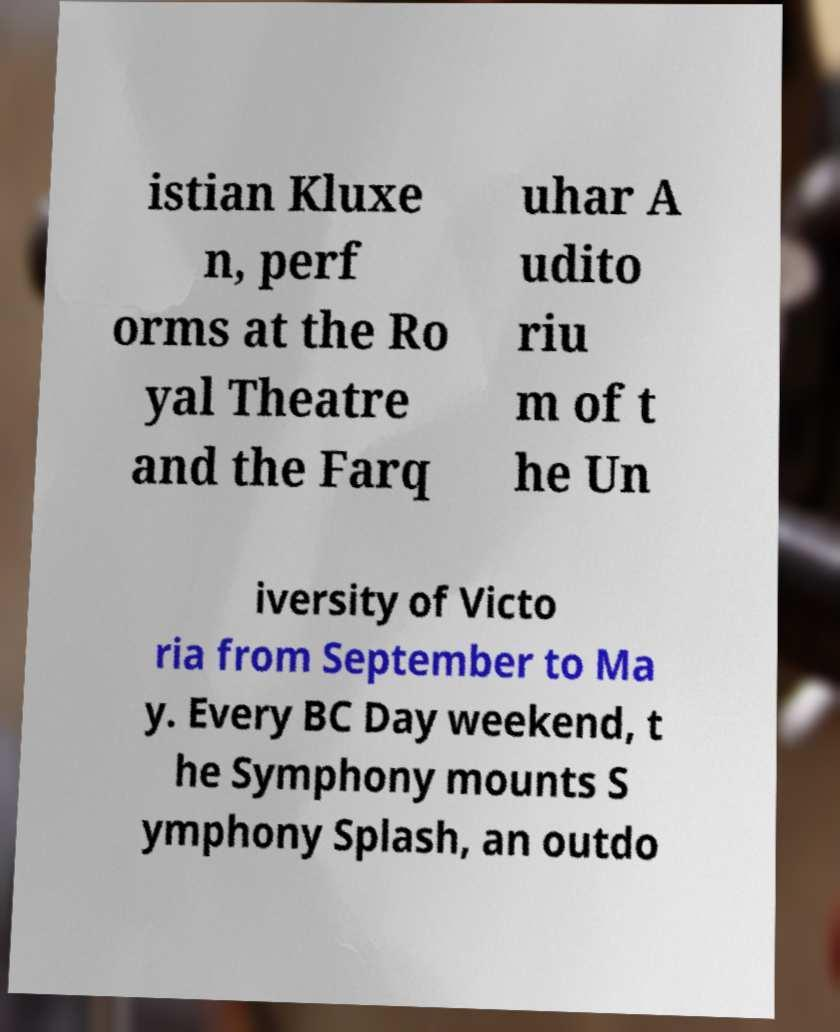There's text embedded in this image that I need extracted. Can you transcribe it verbatim? istian Kluxe n, perf orms at the Ro yal Theatre and the Farq uhar A udito riu m of t he Un iversity of Victo ria from September to Ma y. Every BC Day weekend, t he Symphony mounts S ymphony Splash, an outdo 